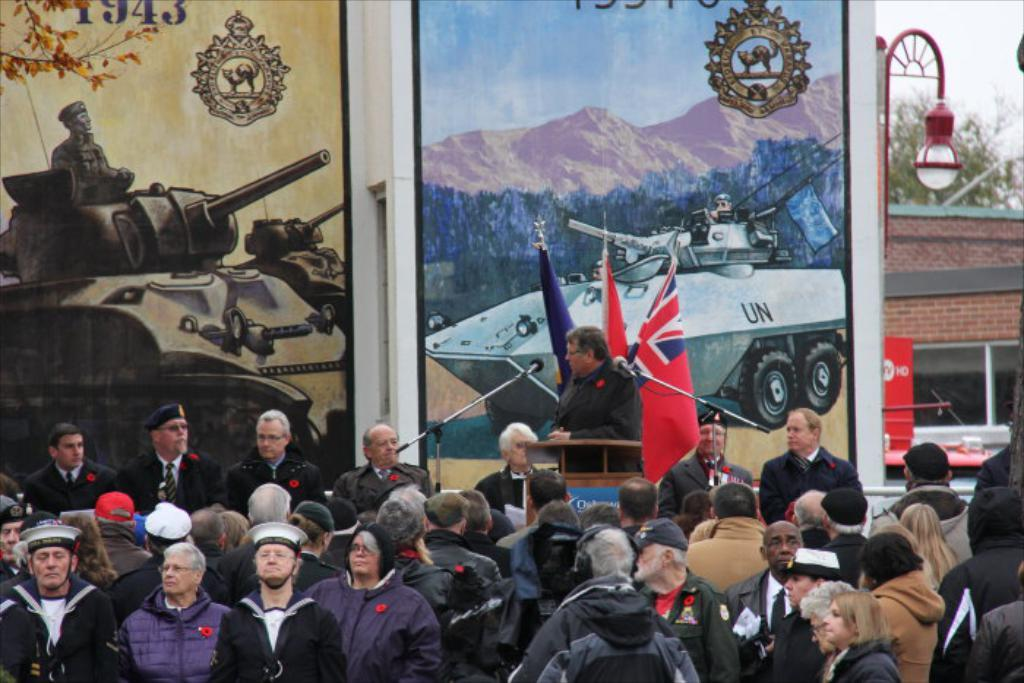How many people are in the image? There are people in the image, but the exact number is not specified. What is one person doing in the image? One person is standing and talking in front of a microphone. What can be seen on the wall in the background? There are boards on the wall in the background. What type of square is being used as a sail in the image? There is no square or sail present in the image. 